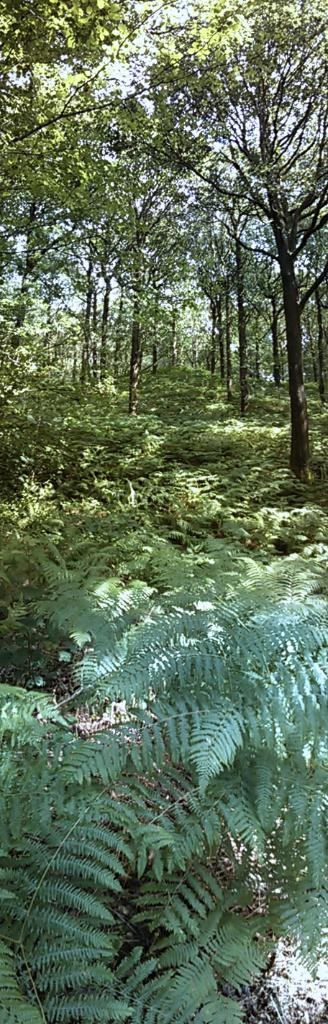What type of vegetation can be seen in the background of the image? There are plants and trees in the background of the image. Can you describe the natural setting visible in the image? The natural setting includes plants and trees in the background. What type of nerve can be seen in the image? There is no nerve present in the image; it features plants and trees in the background. How does the image react to the presence of a border? The image does not react to the presence of a border, as there is no mention of a border in the provided facts. 